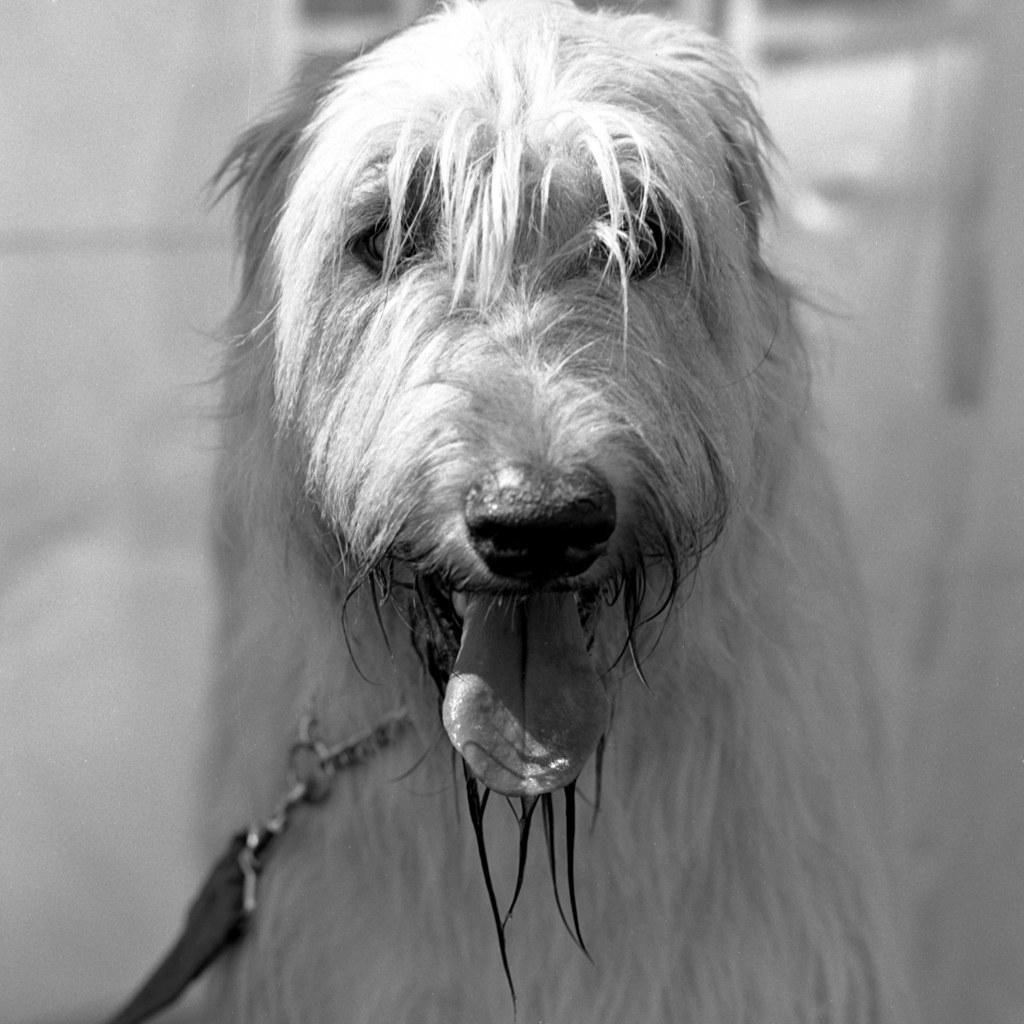What is the main subject in the foreground of the image? There is a dog in the foreground of the image. Can you describe any accessories the dog is wearing? The dog has a belt around its neck. What can be seen in the background of the image? The background of the image is not clear. How many heads of cabbage are visible in the image? There are no heads of cabbage present in the image. What is the dog's level of wealth in the image? The image does not provide any information about the dog's wealth. How many chickens are visible in the image? There are no chickens present in the image. 